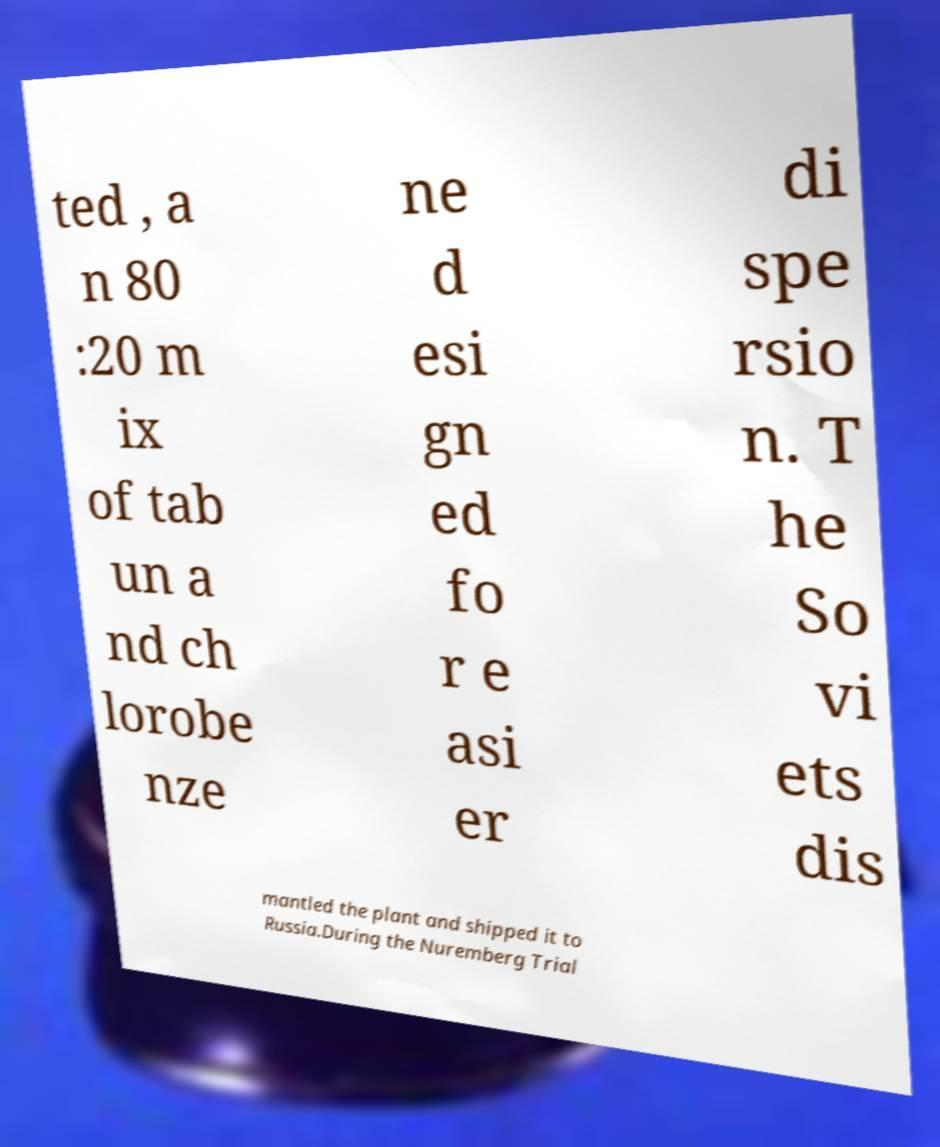For documentation purposes, I need the text within this image transcribed. Could you provide that? ted , a n 80 :20 m ix of tab un a nd ch lorobe nze ne d esi gn ed fo r e asi er di spe rsio n. T he So vi ets dis mantled the plant and shipped it to Russia.During the Nuremberg Trial 